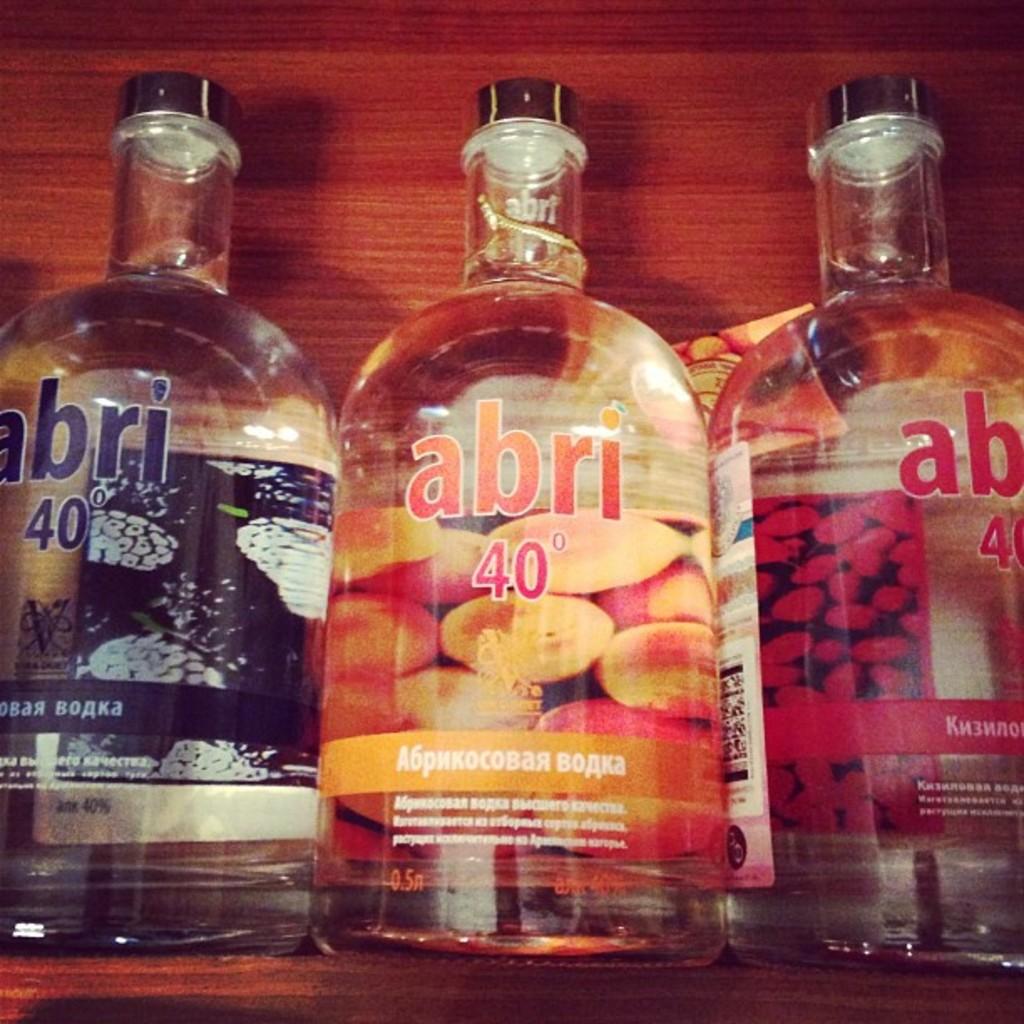What number is written on these bottles?
Provide a short and direct response. 40. 